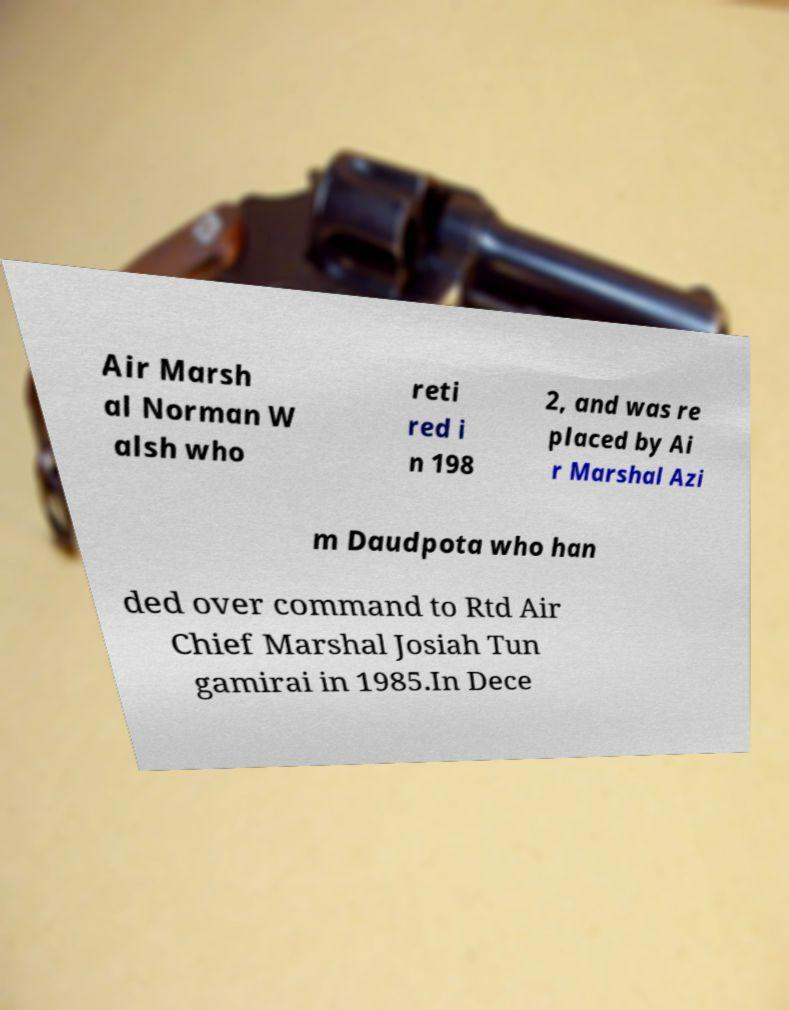Could you extract and type out the text from this image? Air Marsh al Norman W alsh who reti red i n 198 2, and was re placed by Ai r Marshal Azi m Daudpota who han ded over command to Rtd Air Chief Marshal Josiah Tun gamirai in 1985.In Dece 